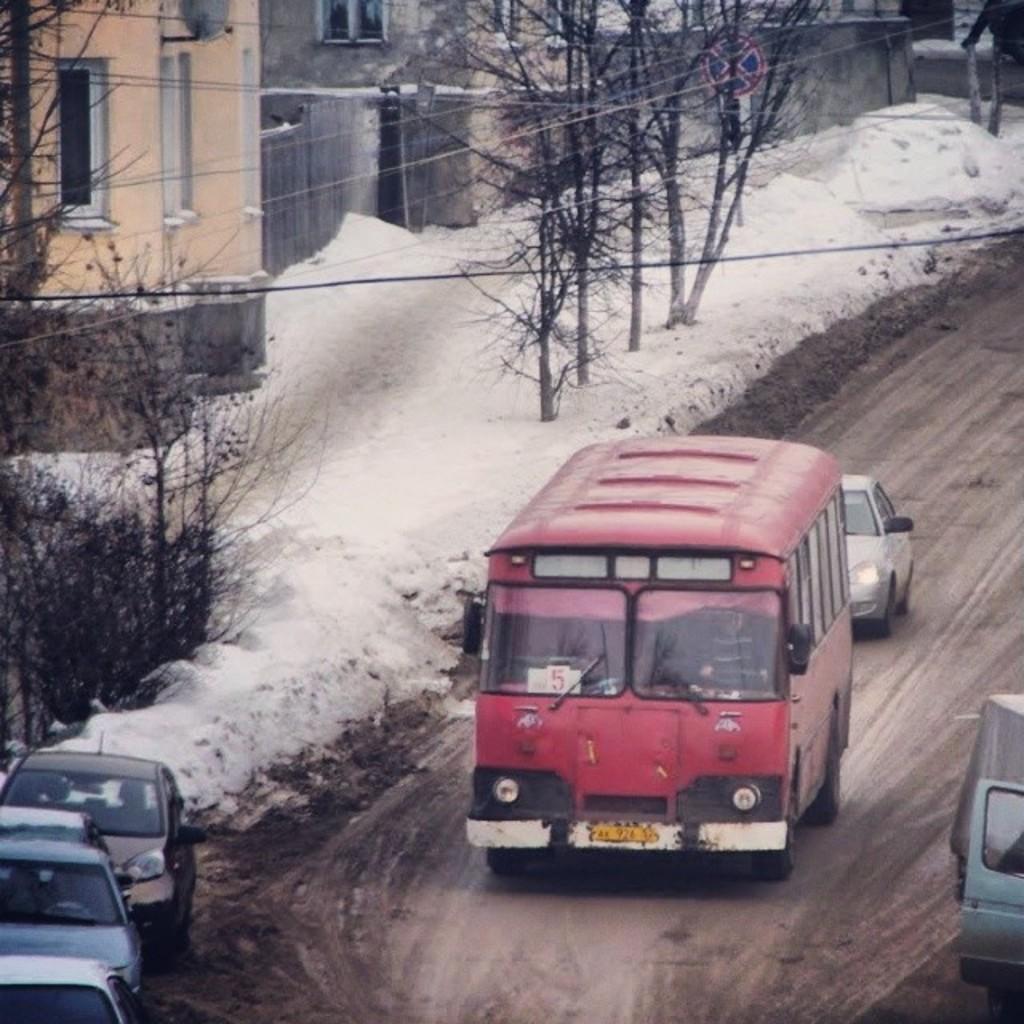In one or two sentences, can you explain what this image depicts? In this picture there is a man who is driving a red bus, behind that there is a car. In the bottom left there are four cars which is parked near to the road. On the left i can see the trees, snow and buildings. At the top there is a sign board near to the wall. In the center there is a black cable. 